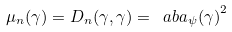<formula> <loc_0><loc_0><loc_500><loc_500>\mu _ { n } ( \gamma ) = D _ { n } ( \gamma , \gamma ) = \ a b { a _ { \psi } ( \gamma ) } ^ { 2 }</formula> 